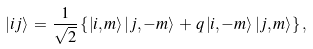Convert formula to latex. <formula><loc_0><loc_0><loc_500><loc_500>\, | i j \rangle \, = \, \frac { 1 } { \sqrt { 2 } } \left \{ \left | i , m \right > \left | j , - m \right > \, + \, q \left | i , - m \right > \left | j , m \right > \right \} ,</formula> 